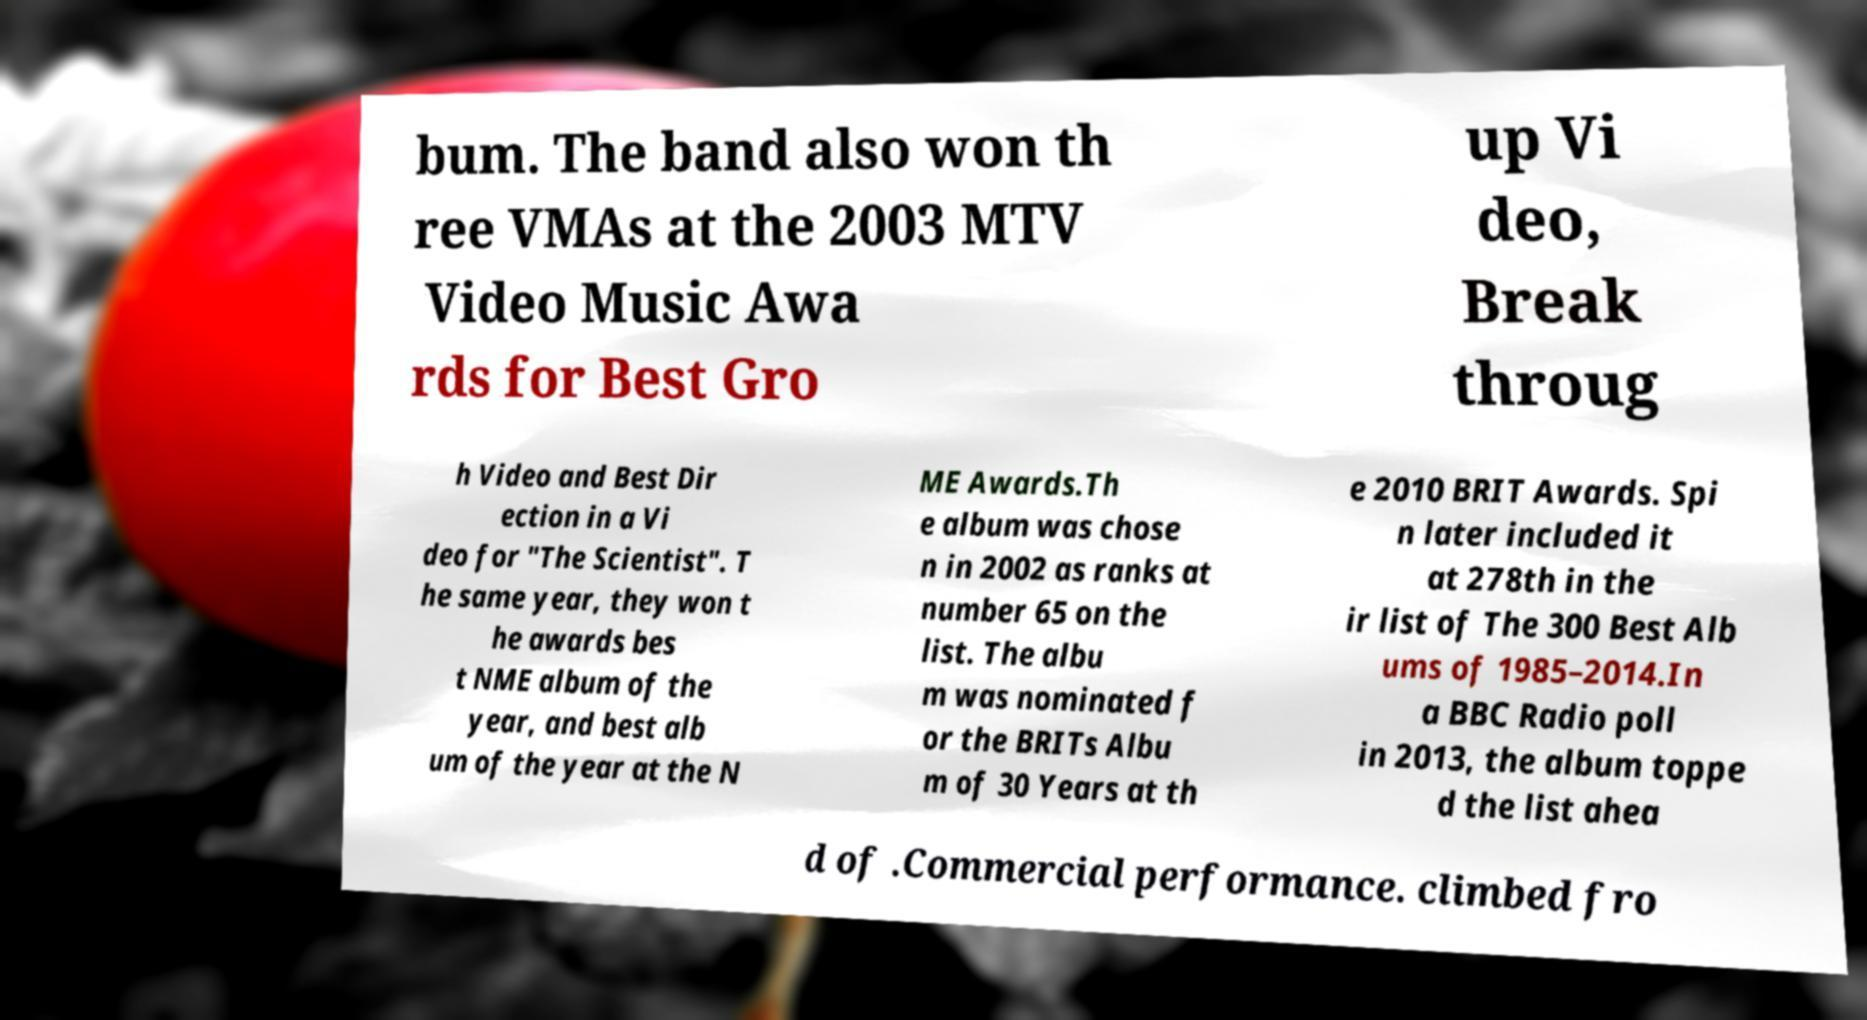Could you extract and type out the text from this image? bum. The band also won th ree VMAs at the 2003 MTV Video Music Awa rds for Best Gro up Vi deo, Break throug h Video and Best Dir ection in a Vi deo for "The Scientist". T he same year, they won t he awards bes t NME album of the year, and best alb um of the year at the N ME Awards.Th e album was chose n in 2002 as ranks at number 65 on the list. The albu m was nominated f or the BRITs Albu m of 30 Years at th e 2010 BRIT Awards. Spi n later included it at 278th in the ir list of The 300 Best Alb ums of 1985–2014.In a BBC Radio poll in 2013, the album toppe d the list ahea d of .Commercial performance. climbed fro 